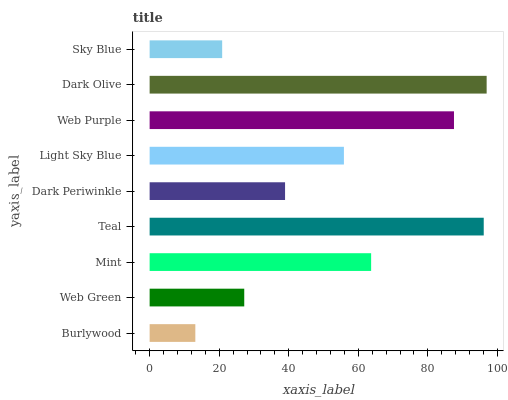Is Burlywood the minimum?
Answer yes or no. Yes. Is Dark Olive the maximum?
Answer yes or no. Yes. Is Web Green the minimum?
Answer yes or no. No. Is Web Green the maximum?
Answer yes or no. No. Is Web Green greater than Burlywood?
Answer yes or no. Yes. Is Burlywood less than Web Green?
Answer yes or no. Yes. Is Burlywood greater than Web Green?
Answer yes or no. No. Is Web Green less than Burlywood?
Answer yes or no. No. Is Light Sky Blue the high median?
Answer yes or no. Yes. Is Light Sky Blue the low median?
Answer yes or no. Yes. Is Burlywood the high median?
Answer yes or no. No. Is Dark Olive the low median?
Answer yes or no. No. 